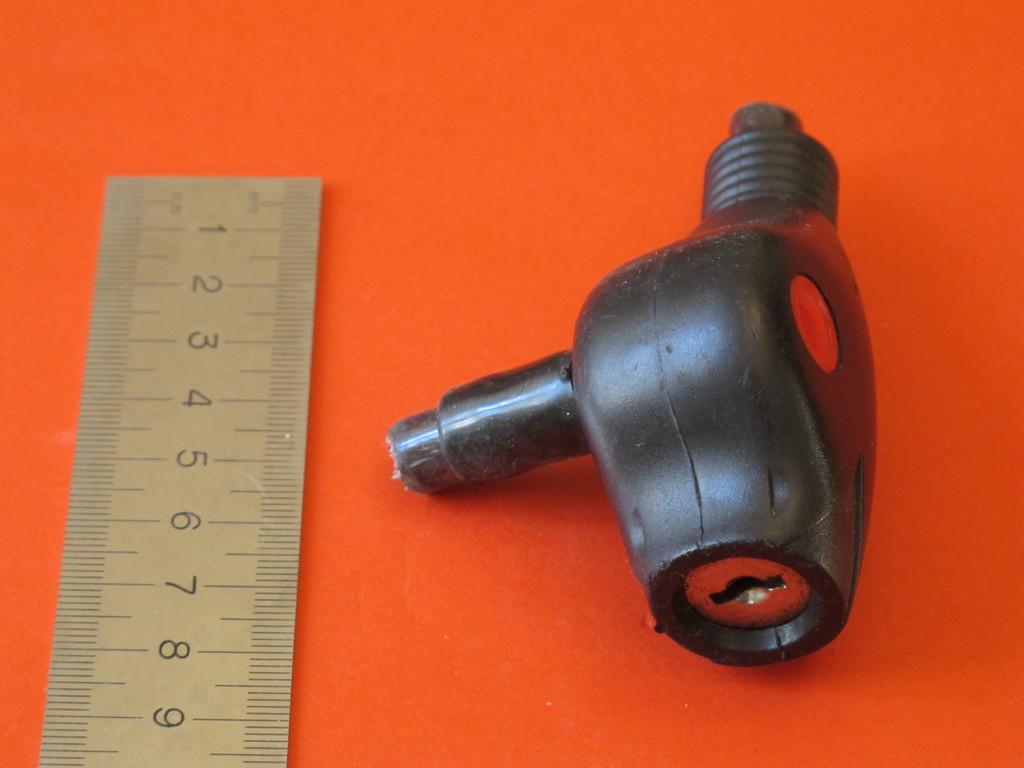How big does the ruler say this piece of material is?
Provide a succinct answer. 8. What is the first number on the ruler?
Offer a terse response. 1. 